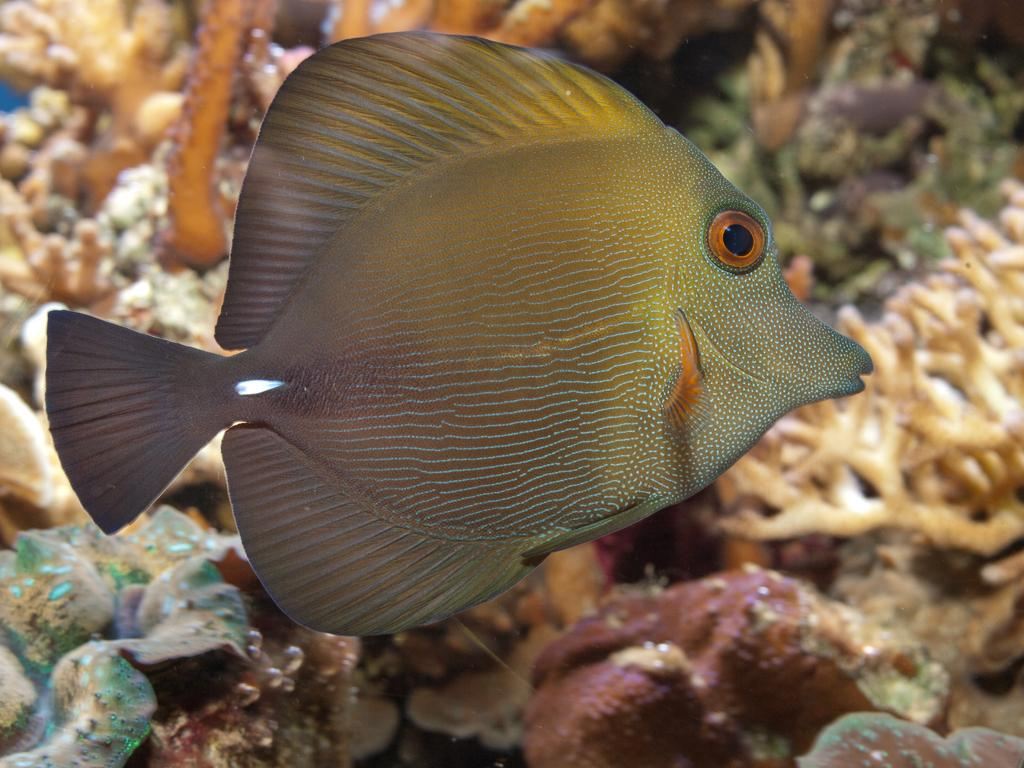What type of animal can be seen in the image? There is a fish in the image. What else is present in the image besides the fish? There are corals in the image. Where are the fish and corals located? The fish and corals are in water. What type of sack is being used to carry the event in the image? There is no event or sack present in the image; it features a fish and corals in water. 